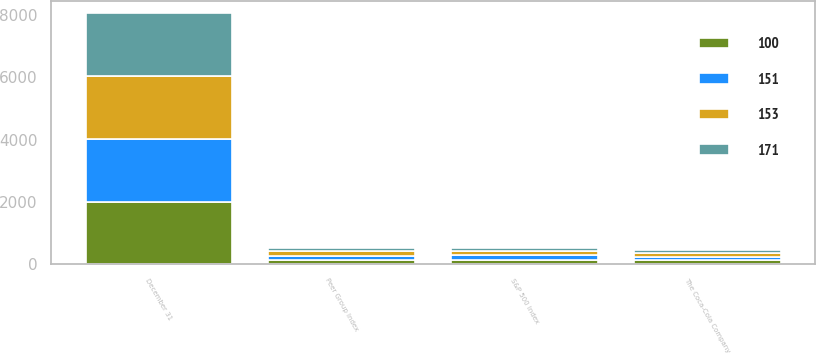Convert chart to OTSL. <chart><loc_0><loc_0><loc_500><loc_500><stacked_bar_chart><ecel><fcel>December 31<fcel>The Coca-Cola Company<fcel>Peer Group Index<fcel>S&P 500 Index<nl><fcel>171<fcel>2012<fcel>100<fcel>100<fcel>100<nl><fcel>151<fcel>2013<fcel>117<fcel>126<fcel>132<nl><fcel>100<fcel>2014<fcel>123<fcel>143<fcel>151<nl><fcel>153<fcel>2015<fcel>130<fcel>163<fcel>153<nl></chart> 